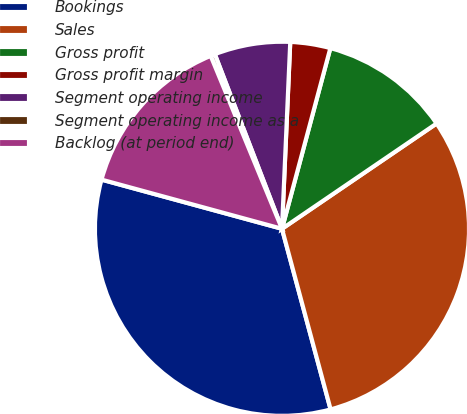<chart> <loc_0><loc_0><loc_500><loc_500><pie_chart><fcel>Bookings<fcel>Sales<fcel>Gross profit<fcel>Gross profit margin<fcel>Segment operating income<fcel>Segment operating income as a<fcel>Backlog (at period end)<nl><fcel>33.42%<fcel>30.33%<fcel>11.32%<fcel>3.46%<fcel>6.55%<fcel>0.38%<fcel>14.54%<nl></chart> 